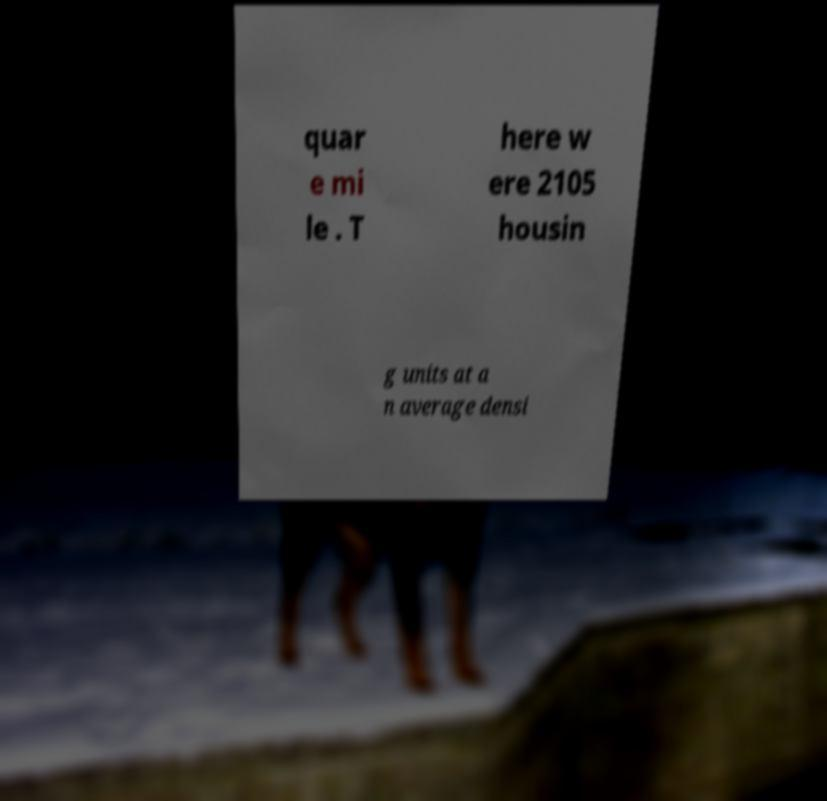Can you accurately transcribe the text from the provided image for me? quar e mi le . T here w ere 2105 housin g units at a n average densi 